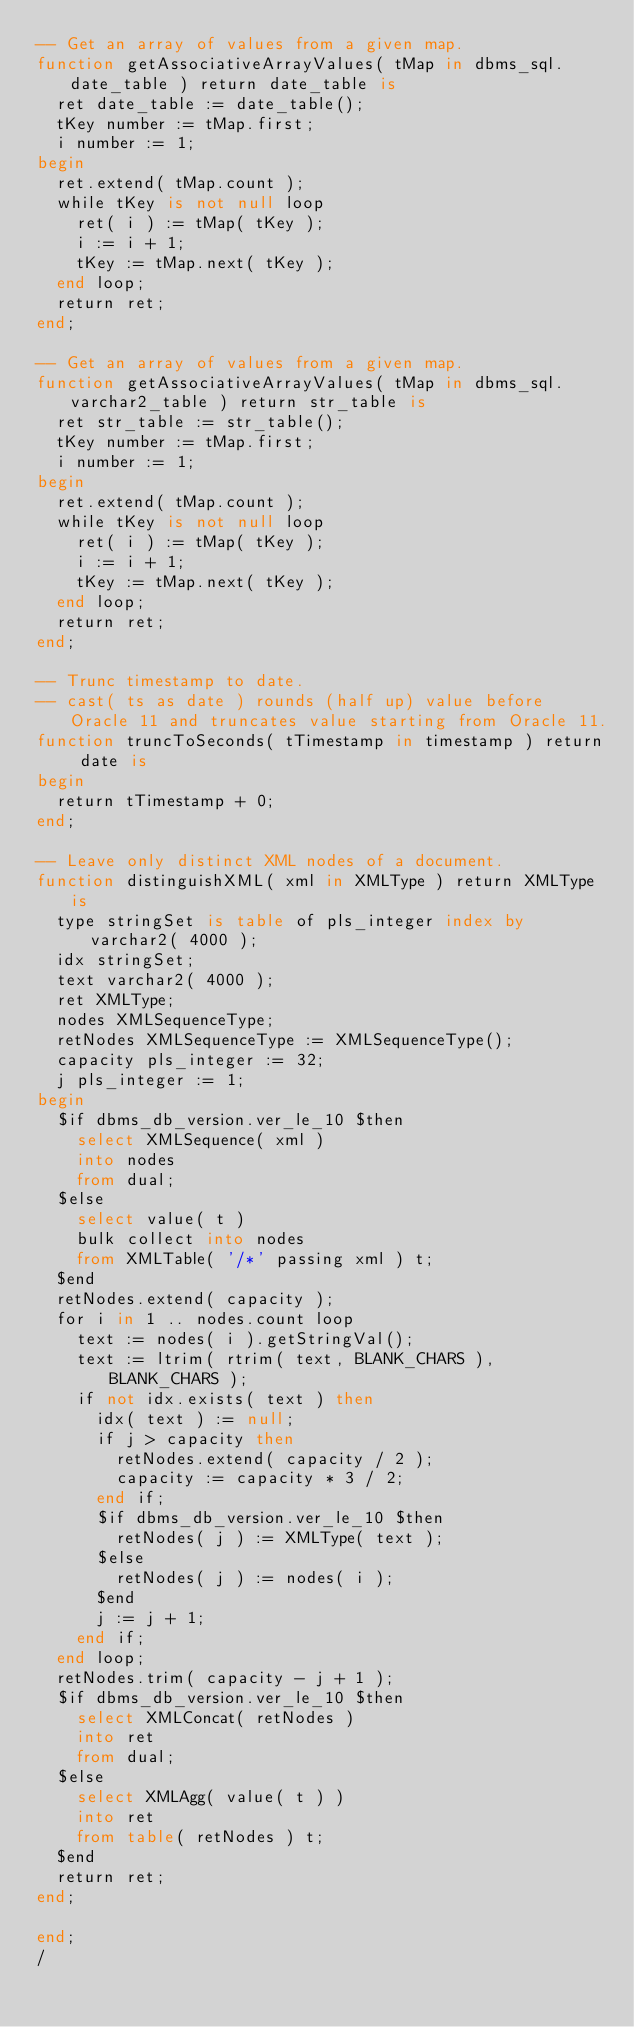<code> <loc_0><loc_0><loc_500><loc_500><_SQL_>-- Get an array of values from a given map.
function getAssociativeArrayValues( tMap in dbms_sql.date_table ) return date_table is
  ret date_table := date_table();
  tKey number := tMap.first;
  i number := 1;
begin
  ret.extend( tMap.count );
  while tKey is not null loop
    ret( i ) := tMap( tKey );
    i := i + 1;
    tKey := tMap.next( tKey );
  end loop;
  return ret;
end;

-- Get an array of values from a given map.
function getAssociativeArrayValues( tMap in dbms_sql.varchar2_table ) return str_table is
  ret str_table := str_table();
  tKey number := tMap.first;
  i number := 1;
begin
  ret.extend( tMap.count );
  while tKey is not null loop
    ret( i ) := tMap( tKey );
    i := i + 1;
    tKey := tMap.next( tKey );
  end loop;
  return ret;
end;

-- Trunc timestamp to date.
-- cast( ts as date ) rounds (half up) value before Oracle 11 and truncates value starting from Oracle 11.
function truncToSeconds( tTimestamp in timestamp ) return date is
begin
  return tTimestamp + 0;
end;

-- Leave only distinct XML nodes of a document.
function distinguishXML( xml in XMLType ) return XMLType is
  type stringSet is table of pls_integer index by varchar2( 4000 );
  idx stringSet;
  text varchar2( 4000 );
  ret XMLType;
  nodes XMLSequenceType;
  retNodes XMLSequenceType := XMLSequenceType();
  capacity pls_integer := 32;
  j pls_integer := 1;
begin
  $if dbms_db_version.ver_le_10 $then
    select XMLSequence( xml )
    into nodes
    from dual;
  $else
    select value( t )
    bulk collect into nodes
    from XMLTable( '/*' passing xml ) t;
  $end
  retNodes.extend( capacity );
  for i in 1 .. nodes.count loop
    text := nodes( i ).getStringVal();
    text := ltrim( rtrim( text, BLANK_CHARS ), BLANK_CHARS );
    if not idx.exists( text ) then
      idx( text ) := null;
      if j > capacity then
        retNodes.extend( capacity / 2 );
        capacity := capacity * 3 / 2;
      end if;
      $if dbms_db_version.ver_le_10 $then
        retNodes( j ) := XMLType( text );
      $else
        retNodes( j ) := nodes( i );
      $end
      j := j + 1;
    end if;
  end loop;
  retNodes.trim( capacity - j + 1 );
  $if dbms_db_version.ver_le_10 $then
    select XMLConcat( retNodes )
    into ret
    from dual;
  $else
    select XMLAgg( value( t ) )
    into ret
    from table( retNodes ) t;
  $end
  return ret;
end;

end;
/
</code> 